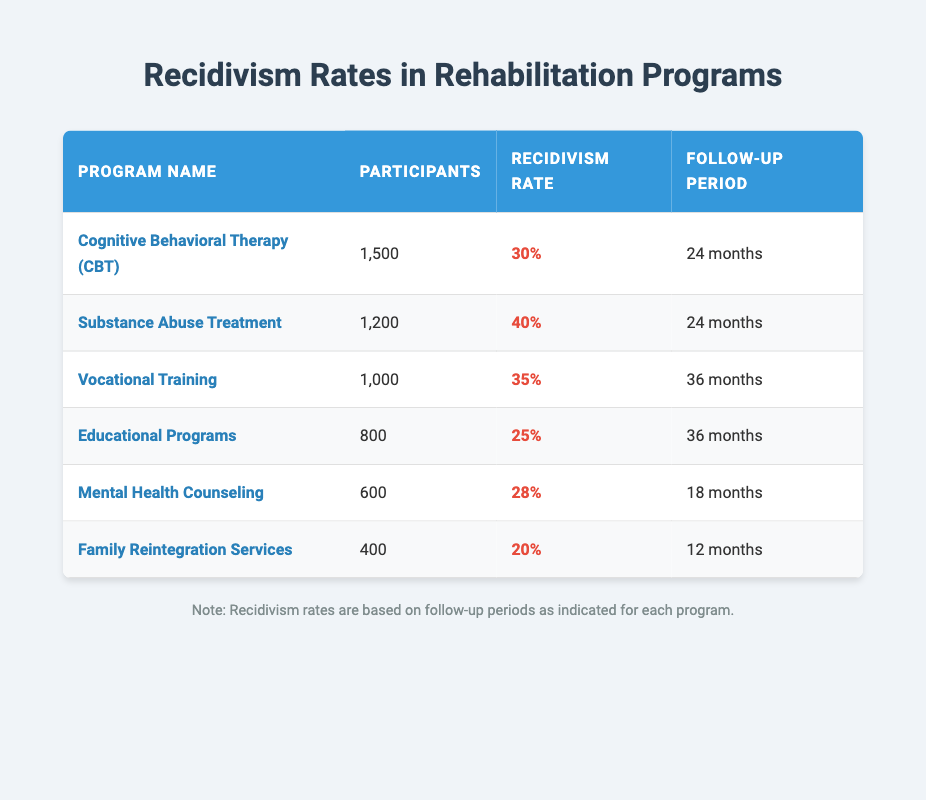What is the recidivism rate for Cognitive Behavioral Therapy? The table lists the recidivism rate for each program. For Cognitive Behavioral Therapy, the rate is explicitly mentioned as 30%.
Answer: 30% How many participants were there in the Substance Abuse Treatment program? The table directly specifies the number of participants for the Substance Abuse Treatment program as 1200.
Answer: 1200 Which program has the lowest recidivism rate? By comparing the recidivism rates from all programs in the table, the Family Reintegration Services has the lowest rate at 20%.
Answer: Family Reintegration Services What is the average recidivism rate of the programs with a follow-up period of 24 months? The programs with a follow-up period of 24 months are Cognitive Behavioral Therapy and Substance Abuse Treatment, with rates of 30% and 40%, respectively. The average is calculated as (30% + 40%) / 2 = 35%.
Answer: 35% True or False: Educational Programs have a higher recidivism rate than Mental Health Counseling. Looking at the table, Educational Programs have a recidivism rate of 25%, while Mental Health Counseling has a rate of 28%. Therefore, the statement is false.
Answer: False What is the difference in recidivism rates between Vocational Training and Family Reintegration Services? The recidivism rate for Vocational Training is 35%, and for Family Reintegration Services, it is 20%. The difference is calculated as 35% - 20% = 15%.
Answer: 15% Which program has more participants: Mental Health Counseling or Family Reintegration Services? The table shows that Mental Health Counseling has 600 participants, while Family Reintegration Services has 400 participants. Therefore, Mental Health Counseling has more participants.
Answer: Mental Health Counseling What is the total number of participants across all listed rehabilitation programs? To find the total number of participants, sum up the participant counts from all programs: 1500 + 1200 + 1000 + 800 + 600 + 400 = 4500.
Answer: 4500 Which program is the most effective in terms of recidivism rate considering the number of participants? To evaluate effectiveness, consider both recidivism rates and participants. Family Reintegration Services has a recidivism rate of 20% with 400 participants, which is lower than all others when calculating the percentage of total participants.
Answer: Family Reintegration Services 